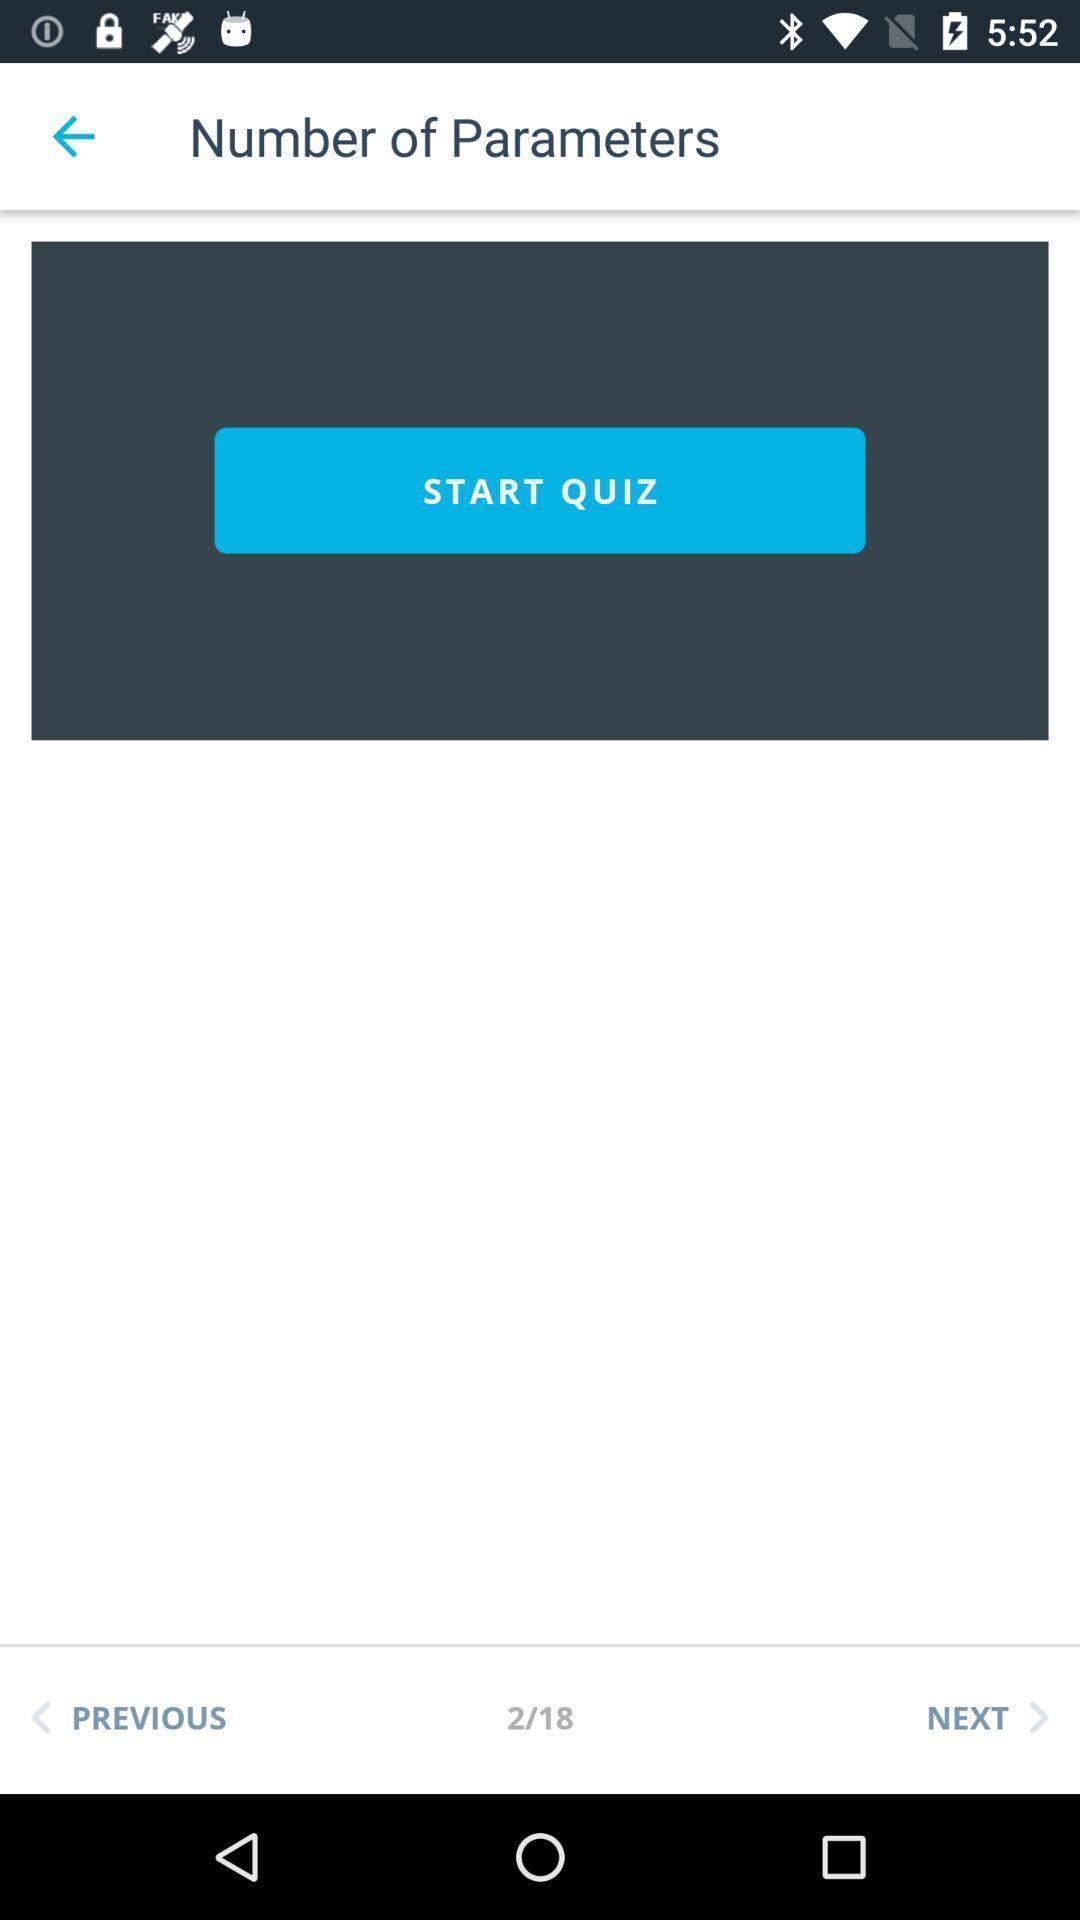Provide a description of this screenshot. Screen displaying quiz under number of parameters page. 